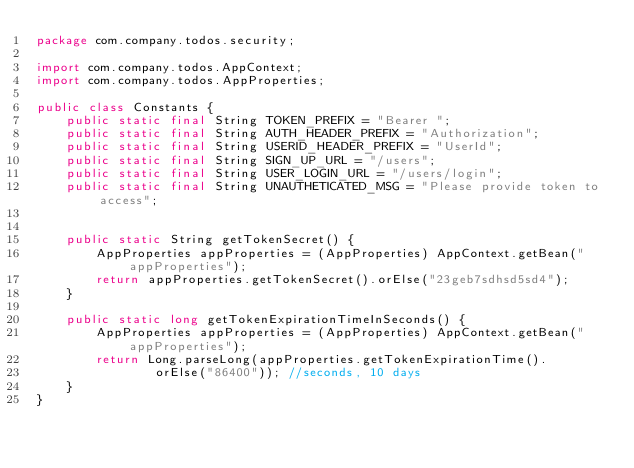Convert code to text. <code><loc_0><loc_0><loc_500><loc_500><_Java_>package com.company.todos.security;

import com.company.todos.AppContext;
import com.company.todos.AppProperties;

public class Constants {
    public static final String TOKEN_PREFIX = "Bearer ";
    public static final String AUTH_HEADER_PREFIX = "Authorization";
    public static final String USERID_HEADER_PREFIX = "UserId";
    public static final String SIGN_UP_URL = "/users";
    public static final String USER_LOGIN_URL = "/users/login";
    public static final String UNAUTHETICATED_MSG = "Please provide token to access";


    public static String getTokenSecret() {
        AppProperties appProperties = (AppProperties) AppContext.getBean("appProperties");
        return appProperties.getTokenSecret().orElse("23geb7sdhsd5sd4");
    }

    public static long getTokenExpirationTimeInSeconds() {
        AppProperties appProperties = (AppProperties) AppContext.getBean("appProperties");
        return Long.parseLong(appProperties.getTokenExpirationTime().
                orElse("86400")); //seconds, 10 days
    }
}
</code> 